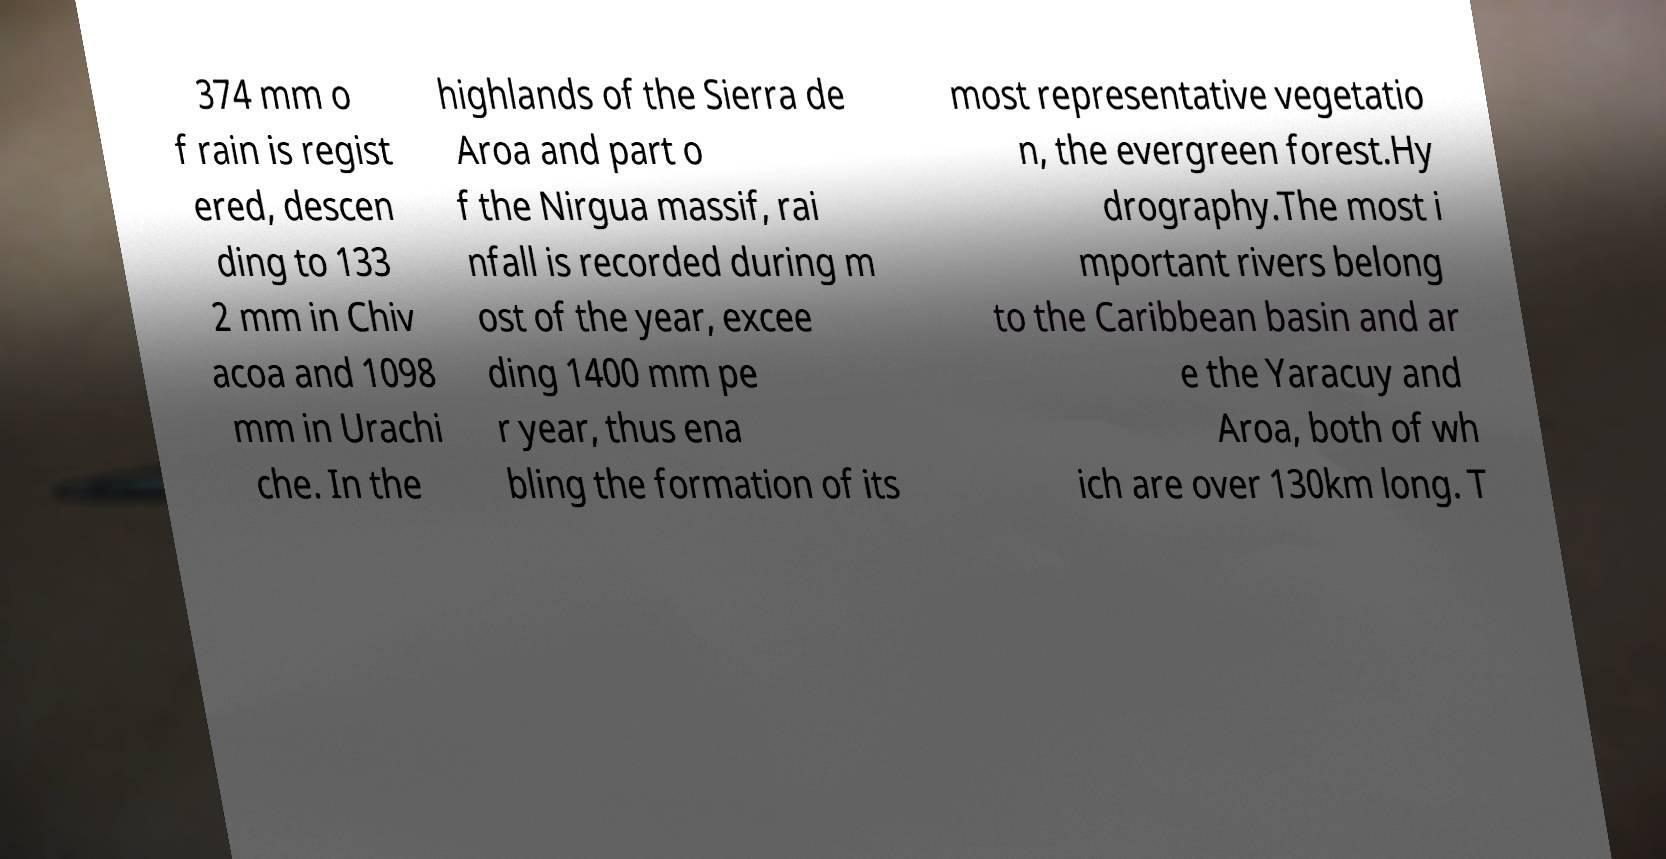Could you extract and type out the text from this image? 374 mm o f rain is regist ered, descen ding to 133 2 mm in Chiv acoa and 1098 mm in Urachi che. In the highlands of the Sierra de Aroa and part o f the Nirgua massif, rai nfall is recorded during m ost of the year, excee ding 1400 mm pe r year, thus ena bling the formation of its most representative vegetatio n, the evergreen forest.Hy drography.The most i mportant rivers belong to the Caribbean basin and ar e the Yaracuy and Aroa, both of wh ich are over 130km long. T 